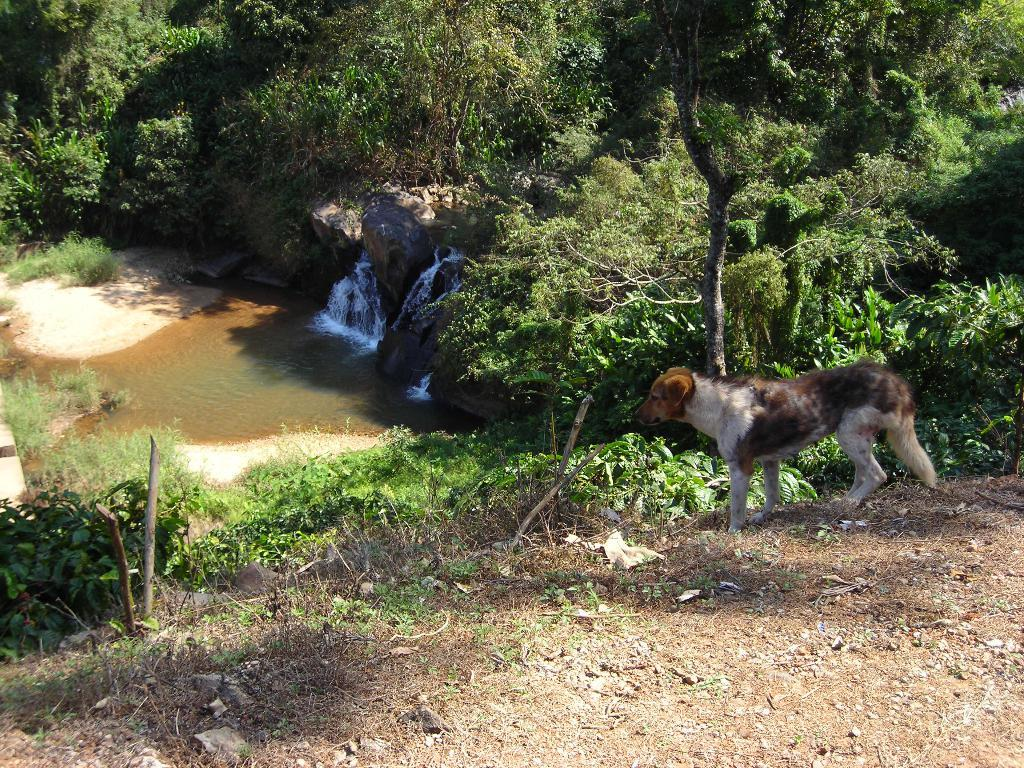What type of animal can be seen in the image? There is a dog in the image. What can be seen in the distance behind the dog? There are trees, rocks, and water visible in the background of the image. What is the surface that the dog is standing on? There is ground at the bottom of the image. How does the dog use the stamp in the image? There is no stamp present in the image, so the dog cannot use it. 